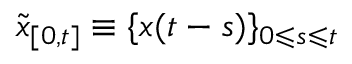<formula> <loc_0><loc_0><loc_500><loc_500>\tilde { x } _ { [ 0 , t ] } \equiv \{ x ( t - s ) \} _ { 0 \leqslant s \leqslant t }</formula> 